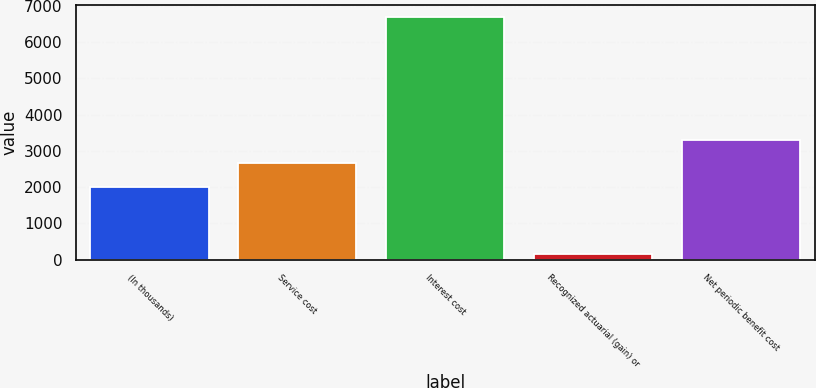Convert chart to OTSL. <chart><loc_0><loc_0><loc_500><loc_500><bar_chart><fcel>(In thousands)<fcel>Service cost<fcel>Interest cost<fcel>Recognized actuarial (gain) or<fcel>Net periodic benefit cost<nl><fcel>2006<fcel>2659.1<fcel>6696<fcel>165<fcel>3312.2<nl></chart> 